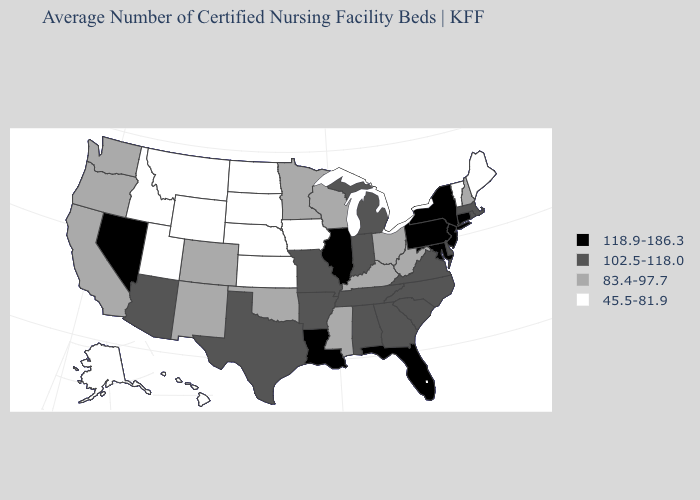Name the states that have a value in the range 45.5-81.9?
Concise answer only. Alaska, Hawaii, Idaho, Iowa, Kansas, Maine, Montana, Nebraska, North Dakota, South Dakota, Utah, Vermont, Wyoming. Name the states that have a value in the range 118.9-186.3?
Give a very brief answer. Connecticut, Florida, Illinois, Louisiana, Maryland, Nevada, New Jersey, New York, Pennsylvania. Which states have the lowest value in the South?
Give a very brief answer. Kentucky, Mississippi, Oklahoma, West Virginia. Among the states that border Delaware , which have the lowest value?
Give a very brief answer. Maryland, New Jersey, Pennsylvania. What is the value of Rhode Island?
Be succinct. 102.5-118.0. What is the lowest value in the West?
Answer briefly. 45.5-81.9. What is the value of Minnesota?
Answer briefly. 83.4-97.7. What is the value of Louisiana?
Concise answer only. 118.9-186.3. What is the value of Wisconsin?
Be succinct. 83.4-97.7. What is the lowest value in the West?
Answer briefly. 45.5-81.9. Name the states that have a value in the range 102.5-118.0?
Answer briefly. Alabama, Arizona, Arkansas, Delaware, Georgia, Indiana, Massachusetts, Michigan, Missouri, North Carolina, Rhode Island, South Carolina, Tennessee, Texas, Virginia. Among the states that border California , does Nevada have the lowest value?
Quick response, please. No. Name the states that have a value in the range 83.4-97.7?
Give a very brief answer. California, Colorado, Kentucky, Minnesota, Mississippi, New Hampshire, New Mexico, Ohio, Oklahoma, Oregon, Washington, West Virginia, Wisconsin. How many symbols are there in the legend?
Give a very brief answer. 4. Does Illinois have the highest value in the MidWest?
Keep it brief. Yes. 